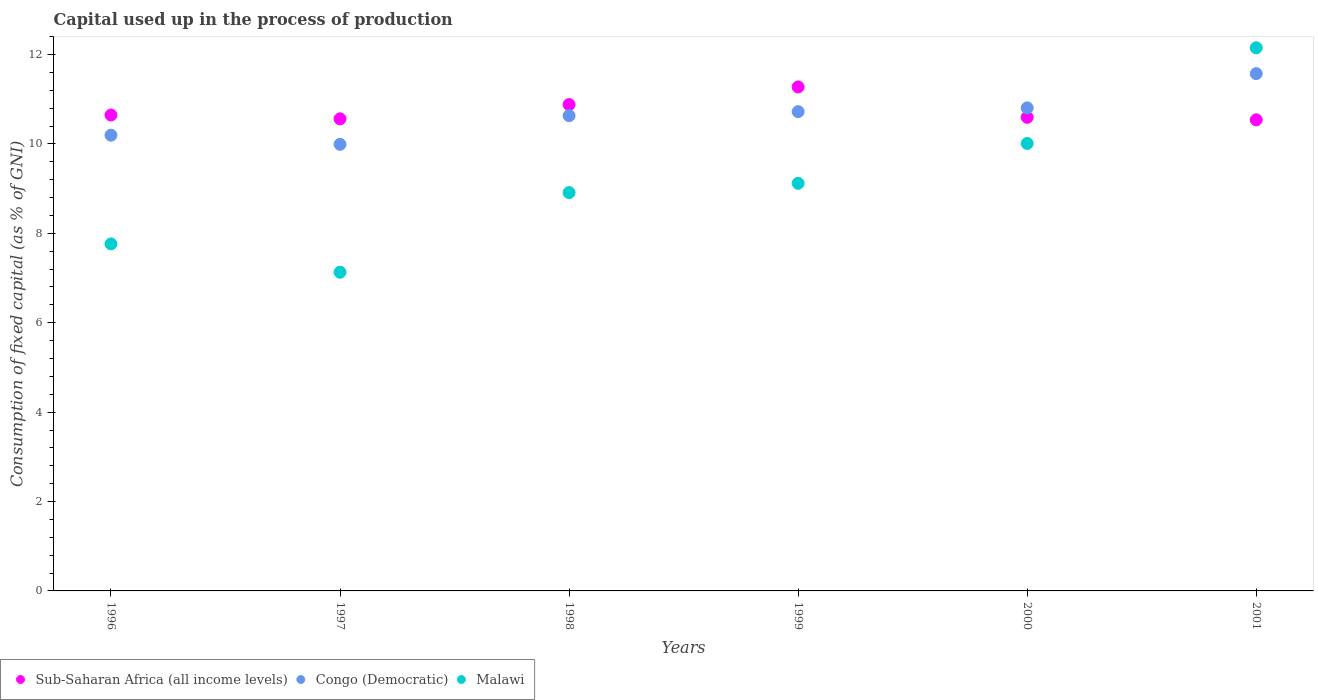What is the capital used up in the process of production in Congo (Democratic) in 2000?
Offer a terse response. 10.81. Across all years, what is the maximum capital used up in the process of production in Sub-Saharan Africa (all income levels)?
Offer a terse response. 11.27. Across all years, what is the minimum capital used up in the process of production in Malawi?
Ensure brevity in your answer.  7.13. In which year was the capital used up in the process of production in Sub-Saharan Africa (all income levels) maximum?
Make the answer very short. 1999. In which year was the capital used up in the process of production in Sub-Saharan Africa (all income levels) minimum?
Offer a terse response. 2001. What is the total capital used up in the process of production in Malawi in the graph?
Your response must be concise. 55.08. What is the difference between the capital used up in the process of production in Malawi in 1996 and that in 1999?
Your answer should be very brief. -1.36. What is the difference between the capital used up in the process of production in Malawi in 1997 and the capital used up in the process of production in Congo (Democratic) in 2001?
Offer a terse response. -4.44. What is the average capital used up in the process of production in Congo (Democratic) per year?
Keep it short and to the point. 10.65. In the year 1999, what is the difference between the capital used up in the process of production in Malawi and capital used up in the process of production in Congo (Democratic)?
Give a very brief answer. -1.6. In how many years, is the capital used up in the process of production in Congo (Democratic) greater than 1.6 %?
Offer a terse response. 6. What is the ratio of the capital used up in the process of production in Sub-Saharan Africa (all income levels) in 2000 to that in 2001?
Your answer should be compact. 1.01. Is the capital used up in the process of production in Sub-Saharan Africa (all income levels) in 1997 less than that in 2000?
Make the answer very short. Yes. Is the difference between the capital used up in the process of production in Malawi in 1998 and 1999 greater than the difference between the capital used up in the process of production in Congo (Democratic) in 1998 and 1999?
Your answer should be very brief. No. What is the difference between the highest and the second highest capital used up in the process of production in Sub-Saharan Africa (all income levels)?
Provide a succinct answer. 0.39. What is the difference between the highest and the lowest capital used up in the process of production in Sub-Saharan Africa (all income levels)?
Offer a very short reply. 0.74. In how many years, is the capital used up in the process of production in Sub-Saharan Africa (all income levels) greater than the average capital used up in the process of production in Sub-Saharan Africa (all income levels) taken over all years?
Provide a short and direct response. 2. Is the sum of the capital used up in the process of production in Congo (Democratic) in 1996 and 1997 greater than the maximum capital used up in the process of production in Sub-Saharan Africa (all income levels) across all years?
Your answer should be compact. Yes. How many dotlines are there?
Your response must be concise. 3. How many years are there in the graph?
Make the answer very short. 6. Are the values on the major ticks of Y-axis written in scientific E-notation?
Offer a very short reply. No. Does the graph contain grids?
Provide a succinct answer. No. How many legend labels are there?
Offer a very short reply. 3. What is the title of the graph?
Ensure brevity in your answer.  Capital used up in the process of production. What is the label or title of the Y-axis?
Your answer should be very brief. Consumption of fixed capital (as % of GNI). What is the Consumption of fixed capital (as % of GNI) in Sub-Saharan Africa (all income levels) in 1996?
Ensure brevity in your answer.  10.65. What is the Consumption of fixed capital (as % of GNI) in Congo (Democratic) in 1996?
Your answer should be compact. 10.2. What is the Consumption of fixed capital (as % of GNI) in Malawi in 1996?
Provide a short and direct response. 7.76. What is the Consumption of fixed capital (as % of GNI) of Sub-Saharan Africa (all income levels) in 1997?
Offer a terse response. 10.56. What is the Consumption of fixed capital (as % of GNI) of Congo (Democratic) in 1997?
Offer a terse response. 9.99. What is the Consumption of fixed capital (as % of GNI) in Malawi in 1997?
Make the answer very short. 7.13. What is the Consumption of fixed capital (as % of GNI) in Sub-Saharan Africa (all income levels) in 1998?
Your answer should be very brief. 10.88. What is the Consumption of fixed capital (as % of GNI) in Congo (Democratic) in 1998?
Your answer should be very brief. 10.63. What is the Consumption of fixed capital (as % of GNI) in Malawi in 1998?
Your answer should be compact. 8.91. What is the Consumption of fixed capital (as % of GNI) of Sub-Saharan Africa (all income levels) in 1999?
Offer a terse response. 11.27. What is the Consumption of fixed capital (as % of GNI) in Congo (Democratic) in 1999?
Keep it short and to the point. 10.72. What is the Consumption of fixed capital (as % of GNI) of Malawi in 1999?
Keep it short and to the point. 9.12. What is the Consumption of fixed capital (as % of GNI) of Sub-Saharan Africa (all income levels) in 2000?
Your answer should be very brief. 10.6. What is the Consumption of fixed capital (as % of GNI) in Congo (Democratic) in 2000?
Your answer should be compact. 10.81. What is the Consumption of fixed capital (as % of GNI) in Malawi in 2000?
Your response must be concise. 10.01. What is the Consumption of fixed capital (as % of GNI) of Sub-Saharan Africa (all income levels) in 2001?
Your answer should be very brief. 10.54. What is the Consumption of fixed capital (as % of GNI) of Congo (Democratic) in 2001?
Provide a short and direct response. 11.57. What is the Consumption of fixed capital (as % of GNI) of Malawi in 2001?
Your response must be concise. 12.15. Across all years, what is the maximum Consumption of fixed capital (as % of GNI) of Sub-Saharan Africa (all income levels)?
Make the answer very short. 11.27. Across all years, what is the maximum Consumption of fixed capital (as % of GNI) in Congo (Democratic)?
Provide a short and direct response. 11.57. Across all years, what is the maximum Consumption of fixed capital (as % of GNI) in Malawi?
Your answer should be very brief. 12.15. Across all years, what is the minimum Consumption of fixed capital (as % of GNI) in Sub-Saharan Africa (all income levels)?
Keep it short and to the point. 10.54. Across all years, what is the minimum Consumption of fixed capital (as % of GNI) in Congo (Democratic)?
Offer a very short reply. 9.99. Across all years, what is the minimum Consumption of fixed capital (as % of GNI) of Malawi?
Provide a succinct answer. 7.13. What is the total Consumption of fixed capital (as % of GNI) of Sub-Saharan Africa (all income levels) in the graph?
Keep it short and to the point. 64.5. What is the total Consumption of fixed capital (as % of GNI) in Congo (Democratic) in the graph?
Your response must be concise. 63.92. What is the total Consumption of fixed capital (as % of GNI) of Malawi in the graph?
Your answer should be compact. 55.08. What is the difference between the Consumption of fixed capital (as % of GNI) of Sub-Saharan Africa (all income levels) in 1996 and that in 1997?
Your response must be concise. 0.09. What is the difference between the Consumption of fixed capital (as % of GNI) in Congo (Democratic) in 1996 and that in 1997?
Ensure brevity in your answer.  0.2. What is the difference between the Consumption of fixed capital (as % of GNI) in Malawi in 1996 and that in 1997?
Offer a terse response. 0.63. What is the difference between the Consumption of fixed capital (as % of GNI) in Sub-Saharan Africa (all income levels) in 1996 and that in 1998?
Your answer should be very brief. -0.23. What is the difference between the Consumption of fixed capital (as % of GNI) in Congo (Democratic) in 1996 and that in 1998?
Offer a terse response. -0.44. What is the difference between the Consumption of fixed capital (as % of GNI) of Malawi in 1996 and that in 1998?
Offer a terse response. -1.15. What is the difference between the Consumption of fixed capital (as % of GNI) of Sub-Saharan Africa (all income levels) in 1996 and that in 1999?
Keep it short and to the point. -0.63. What is the difference between the Consumption of fixed capital (as % of GNI) of Congo (Democratic) in 1996 and that in 1999?
Your answer should be very brief. -0.53. What is the difference between the Consumption of fixed capital (as % of GNI) in Malawi in 1996 and that in 1999?
Provide a short and direct response. -1.36. What is the difference between the Consumption of fixed capital (as % of GNI) of Sub-Saharan Africa (all income levels) in 1996 and that in 2000?
Your answer should be compact. 0.05. What is the difference between the Consumption of fixed capital (as % of GNI) of Congo (Democratic) in 1996 and that in 2000?
Ensure brevity in your answer.  -0.61. What is the difference between the Consumption of fixed capital (as % of GNI) of Malawi in 1996 and that in 2000?
Provide a succinct answer. -2.25. What is the difference between the Consumption of fixed capital (as % of GNI) of Sub-Saharan Africa (all income levels) in 1996 and that in 2001?
Keep it short and to the point. 0.11. What is the difference between the Consumption of fixed capital (as % of GNI) in Congo (Democratic) in 1996 and that in 2001?
Your answer should be very brief. -1.38. What is the difference between the Consumption of fixed capital (as % of GNI) of Malawi in 1996 and that in 2001?
Provide a short and direct response. -4.39. What is the difference between the Consumption of fixed capital (as % of GNI) of Sub-Saharan Africa (all income levels) in 1997 and that in 1998?
Ensure brevity in your answer.  -0.32. What is the difference between the Consumption of fixed capital (as % of GNI) in Congo (Democratic) in 1997 and that in 1998?
Offer a very short reply. -0.64. What is the difference between the Consumption of fixed capital (as % of GNI) of Malawi in 1997 and that in 1998?
Make the answer very short. -1.78. What is the difference between the Consumption of fixed capital (as % of GNI) in Sub-Saharan Africa (all income levels) in 1997 and that in 1999?
Your answer should be compact. -0.71. What is the difference between the Consumption of fixed capital (as % of GNI) in Congo (Democratic) in 1997 and that in 1999?
Give a very brief answer. -0.73. What is the difference between the Consumption of fixed capital (as % of GNI) in Malawi in 1997 and that in 1999?
Your response must be concise. -1.99. What is the difference between the Consumption of fixed capital (as % of GNI) in Sub-Saharan Africa (all income levels) in 1997 and that in 2000?
Provide a short and direct response. -0.03. What is the difference between the Consumption of fixed capital (as % of GNI) of Congo (Democratic) in 1997 and that in 2000?
Give a very brief answer. -0.82. What is the difference between the Consumption of fixed capital (as % of GNI) in Malawi in 1997 and that in 2000?
Offer a very short reply. -2.88. What is the difference between the Consumption of fixed capital (as % of GNI) in Sub-Saharan Africa (all income levels) in 1997 and that in 2001?
Give a very brief answer. 0.02. What is the difference between the Consumption of fixed capital (as % of GNI) in Congo (Democratic) in 1997 and that in 2001?
Your answer should be compact. -1.58. What is the difference between the Consumption of fixed capital (as % of GNI) in Malawi in 1997 and that in 2001?
Your answer should be very brief. -5.02. What is the difference between the Consumption of fixed capital (as % of GNI) of Sub-Saharan Africa (all income levels) in 1998 and that in 1999?
Your answer should be very brief. -0.39. What is the difference between the Consumption of fixed capital (as % of GNI) of Congo (Democratic) in 1998 and that in 1999?
Offer a very short reply. -0.09. What is the difference between the Consumption of fixed capital (as % of GNI) of Malawi in 1998 and that in 1999?
Keep it short and to the point. -0.21. What is the difference between the Consumption of fixed capital (as % of GNI) in Sub-Saharan Africa (all income levels) in 1998 and that in 2000?
Ensure brevity in your answer.  0.28. What is the difference between the Consumption of fixed capital (as % of GNI) of Congo (Democratic) in 1998 and that in 2000?
Your response must be concise. -0.18. What is the difference between the Consumption of fixed capital (as % of GNI) in Malawi in 1998 and that in 2000?
Provide a short and direct response. -1.1. What is the difference between the Consumption of fixed capital (as % of GNI) of Sub-Saharan Africa (all income levels) in 1998 and that in 2001?
Your response must be concise. 0.34. What is the difference between the Consumption of fixed capital (as % of GNI) in Congo (Democratic) in 1998 and that in 2001?
Your response must be concise. -0.94. What is the difference between the Consumption of fixed capital (as % of GNI) in Malawi in 1998 and that in 2001?
Offer a very short reply. -3.24. What is the difference between the Consumption of fixed capital (as % of GNI) of Sub-Saharan Africa (all income levels) in 1999 and that in 2000?
Provide a succinct answer. 0.68. What is the difference between the Consumption of fixed capital (as % of GNI) of Congo (Democratic) in 1999 and that in 2000?
Make the answer very short. -0.08. What is the difference between the Consumption of fixed capital (as % of GNI) of Malawi in 1999 and that in 2000?
Provide a short and direct response. -0.89. What is the difference between the Consumption of fixed capital (as % of GNI) of Sub-Saharan Africa (all income levels) in 1999 and that in 2001?
Offer a terse response. 0.74. What is the difference between the Consumption of fixed capital (as % of GNI) in Congo (Democratic) in 1999 and that in 2001?
Your response must be concise. -0.85. What is the difference between the Consumption of fixed capital (as % of GNI) of Malawi in 1999 and that in 2001?
Your response must be concise. -3.03. What is the difference between the Consumption of fixed capital (as % of GNI) of Sub-Saharan Africa (all income levels) in 2000 and that in 2001?
Give a very brief answer. 0.06. What is the difference between the Consumption of fixed capital (as % of GNI) in Congo (Democratic) in 2000 and that in 2001?
Offer a very short reply. -0.77. What is the difference between the Consumption of fixed capital (as % of GNI) of Malawi in 2000 and that in 2001?
Your answer should be very brief. -2.14. What is the difference between the Consumption of fixed capital (as % of GNI) of Sub-Saharan Africa (all income levels) in 1996 and the Consumption of fixed capital (as % of GNI) of Congo (Democratic) in 1997?
Give a very brief answer. 0.66. What is the difference between the Consumption of fixed capital (as % of GNI) of Sub-Saharan Africa (all income levels) in 1996 and the Consumption of fixed capital (as % of GNI) of Malawi in 1997?
Provide a short and direct response. 3.52. What is the difference between the Consumption of fixed capital (as % of GNI) of Congo (Democratic) in 1996 and the Consumption of fixed capital (as % of GNI) of Malawi in 1997?
Your answer should be compact. 3.07. What is the difference between the Consumption of fixed capital (as % of GNI) in Sub-Saharan Africa (all income levels) in 1996 and the Consumption of fixed capital (as % of GNI) in Congo (Democratic) in 1998?
Provide a succinct answer. 0.02. What is the difference between the Consumption of fixed capital (as % of GNI) in Sub-Saharan Africa (all income levels) in 1996 and the Consumption of fixed capital (as % of GNI) in Malawi in 1998?
Your answer should be very brief. 1.74. What is the difference between the Consumption of fixed capital (as % of GNI) of Congo (Democratic) in 1996 and the Consumption of fixed capital (as % of GNI) of Malawi in 1998?
Keep it short and to the point. 1.28. What is the difference between the Consumption of fixed capital (as % of GNI) in Sub-Saharan Africa (all income levels) in 1996 and the Consumption of fixed capital (as % of GNI) in Congo (Democratic) in 1999?
Provide a short and direct response. -0.08. What is the difference between the Consumption of fixed capital (as % of GNI) of Sub-Saharan Africa (all income levels) in 1996 and the Consumption of fixed capital (as % of GNI) of Malawi in 1999?
Give a very brief answer. 1.53. What is the difference between the Consumption of fixed capital (as % of GNI) of Congo (Democratic) in 1996 and the Consumption of fixed capital (as % of GNI) of Malawi in 1999?
Your response must be concise. 1.08. What is the difference between the Consumption of fixed capital (as % of GNI) in Sub-Saharan Africa (all income levels) in 1996 and the Consumption of fixed capital (as % of GNI) in Congo (Democratic) in 2000?
Make the answer very short. -0.16. What is the difference between the Consumption of fixed capital (as % of GNI) in Sub-Saharan Africa (all income levels) in 1996 and the Consumption of fixed capital (as % of GNI) in Malawi in 2000?
Your response must be concise. 0.64. What is the difference between the Consumption of fixed capital (as % of GNI) of Congo (Democratic) in 1996 and the Consumption of fixed capital (as % of GNI) of Malawi in 2000?
Your answer should be compact. 0.19. What is the difference between the Consumption of fixed capital (as % of GNI) in Sub-Saharan Africa (all income levels) in 1996 and the Consumption of fixed capital (as % of GNI) in Congo (Democratic) in 2001?
Your answer should be very brief. -0.93. What is the difference between the Consumption of fixed capital (as % of GNI) of Sub-Saharan Africa (all income levels) in 1996 and the Consumption of fixed capital (as % of GNI) of Malawi in 2001?
Make the answer very short. -1.5. What is the difference between the Consumption of fixed capital (as % of GNI) in Congo (Democratic) in 1996 and the Consumption of fixed capital (as % of GNI) in Malawi in 2001?
Your answer should be very brief. -1.96. What is the difference between the Consumption of fixed capital (as % of GNI) of Sub-Saharan Africa (all income levels) in 1997 and the Consumption of fixed capital (as % of GNI) of Congo (Democratic) in 1998?
Offer a terse response. -0.07. What is the difference between the Consumption of fixed capital (as % of GNI) in Sub-Saharan Africa (all income levels) in 1997 and the Consumption of fixed capital (as % of GNI) in Malawi in 1998?
Your answer should be very brief. 1.65. What is the difference between the Consumption of fixed capital (as % of GNI) of Congo (Democratic) in 1997 and the Consumption of fixed capital (as % of GNI) of Malawi in 1998?
Make the answer very short. 1.08. What is the difference between the Consumption of fixed capital (as % of GNI) of Sub-Saharan Africa (all income levels) in 1997 and the Consumption of fixed capital (as % of GNI) of Congo (Democratic) in 1999?
Give a very brief answer. -0.16. What is the difference between the Consumption of fixed capital (as % of GNI) of Sub-Saharan Africa (all income levels) in 1997 and the Consumption of fixed capital (as % of GNI) of Malawi in 1999?
Provide a succinct answer. 1.44. What is the difference between the Consumption of fixed capital (as % of GNI) of Congo (Democratic) in 1997 and the Consumption of fixed capital (as % of GNI) of Malawi in 1999?
Your response must be concise. 0.87. What is the difference between the Consumption of fixed capital (as % of GNI) in Sub-Saharan Africa (all income levels) in 1997 and the Consumption of fixed capital (as % of GNI) in Congo (Democratic) in 2000?
Provide a short and direct response. -0.25. What is the difference between the Consumption of fixed capital (as % of GNI) of Sub-Saharan Africa (all income levels) in 1997 and the Consumption of fixed capital (as % of GNI) of Malawi in 2000?
Provide a succinct answer. 0.55. What is the difference between the Consumption of fixed capital (as % of GNI) of Congo (Democratic) in 1997 and the Consumption of fixed capital (as % of GNI) of Malawi in 2000?
Give a very brief answer. -0.02. What is the difference between the Consumption of fixed capital (as % of GNI) of Sub-Saharan Africa (all income levels) in 1997 and the Consumption of fixed capital (as % of GNI) of Congo (Democratic) in 2001?
Provide a short and direct response. -1.01. What is the difference between the Consumption of fixed capital (as % of GNI) of Sub-Saharan Africa (all income levels) in 1997 and the Consumption of fixed capital (as % of GNI) of Malawi in 2001?
Your response must be concise. -1.59. What is the difference between the Consumption of fixed capital (as % of GNI) of Congo (Democratic) in 1997 and the Consumption of fixed capital (as % of GNI) of Malawi in 2001?
Ensure brevity in your answer.  -2.16. What is the difference between the Consumption of fixed capital (as % of GNI) of Sub-Saharan Africa (all income levels) in 1998 and the Consumption of fixed capital (as % of GNI) of Congo (Democratic) in 1999?
Ensure brevity in your answer.  0.16. What is the difference between the Consumption of fixed capital (as % of GNI) in Sub-Saharan Africa (all income levels) in 1998 and the Consumption of fixed capital (as % of GNI) in Malawi in 1999?
Provide a succinct answer. 1.76. What is the difference between the Consumption of fixed capital (as % of GNI) in Congo (Democratic) in 1998 and the Consumption of fixed capital (as % of GNI) in Malawi in 1999?
Make the answer very short. 1.51. What is the difference between the Consumption of fixed capital (as % of GNI) of Sub-Saharan Africa (all income levels) in 1998 and the Consumption of fixed capital (as % of GNI) of Congo (Democratic) in 2000?
Provide a succinct answer. 0.07. What is the difference between the Consumption of fixed capital (as % of GNI) of Sub-Saharan Africa (all income levels) in 1998 and the Consumption of fixed capital (as % of GNI) of Malawi in 2000?
Your response must be concise. 0.87. What is the difference between the Consumption of fixed capital (as % of GNI) in Congo (Democratic) in 1998 and the Consumption of fixed capital (as % of GNI) in Malawi in 2000?
Your answer should be very brief. 0.62. What is the difference between the Consumption of fixed capital (as % of GNI) in Sub-Saharan Africa (all income levels) in 1998 and the Consumption of fixed capital (as % of GNI) in Congo (Democratic) in 2001?
Offer a very short reply. -0.69. What is the difference between the Consumption of fixed capital (as % of GNI) of Sub-Saharan Africa (all income levels) in 1998 and the Consumption of fixed capital (as % of GNI) of Malawi in 2001?
Ensure brevity in your answer.  -1.27. What is the difference between the Consumption of fixed capital (as % of GNI) in Congo (Democratic) in 1998 and the Consumption of fixed capital (as % of GNI) in Malawi in 2001?
Your answer should be very brief. -1.52. What is the difference between the Consumption of fixed capital (as % of GNI) of Sub-Saharan Africa (all income levels) in 1999 and the Consumption of fixed capital (as % of GNI) of Congo (Democratic) in 2000?
Your answer should be very brief. 0.47. What is the difference between the Consumption of fixed capital (as % of GNI) of Sub-Saharan Africa (all income levels) in 1999 and the Consumption of fixed capital (as % of GNI) of Malawi in 2000?
Offer a very short reply. 1.26. What is the difference between the Consumption of fixed capital (as % of GNI) of Congo (Democratic) in 1999 and the Consumption of fixed capital (as % of GNI) of Malawi in 2000?
Ensure brevity in your answer.  0.71. What is the difference between the Consumption of fixed capital (as % of GNI) of Sub-Saharan Africa (all income levels) in 1999 and the Consumption of fixed capital (as % of GNI) of Congo (Democratic) in 2001?
Your answer should be very brief. -0.3. What is the difference between the Consumption of fixed capital (as % of GNI) of Sub-Saharan Africa (all income levels) in 1999 and the Consumption of fixed capital (as % of GNI) of Malawi in 2001?
Offer a terse response. -0.88. What is the difference between the Consumption of fixed capital (as % of GNI) of Congo (Democratic) in 1999 and the Consumption of fixed capital (as % of GNI) of Malawi in 2001?
Provide a succinct answer. -1.43. What is the difference between the Consumption of fixed capital (as % of GNI) in Sub-Saharan Africa (all income levels) in 2000 and the Consumption of fixed capital (as % of GNI) in Congo (Democratic) in 2001?
Offer a terse response. -0.98. What is the difference between the Consumption of fixed capital (as % of GNI) of Sub-Saharan Africa (all income levels) in 2000 and the Consumption of fixed capital (as % of GNI) of Malawi in 2001?
Keep it short and to the point. -1.55. What is the difference between the Consumption of fixed capital (as % of GNI) of Congo (Democratic) in 2000 and the Consumption of fixed capital (as % of GNI) of Malawi in 2001?
Provide a short and direct response. -1.34. What is the average Consumption of fixed capital (as % of GNI) in Sub-Saharan Africa (all income levels) per year?
Your answer should be compact. 10.75. What is the average Consumption of fixed capital (as % of GNI) in Congo (Democratic) per year?
Make the answer very short. 10.65. What is the average Consumption of fixed capital (as % of GNI) of Malawi per year?
Provide a succinct answer. 9.18. In the year 1996, what is the difference between the Consumption of fixed capital (as % of GNI) in Sub-Saharan Africa (all income levels) and Consumption of fixed capital (as % of GNI) in Congo (Democratic)?
Provide a short and direct response. 0.45. In the year 1996, what is the difference between the Consumption of fixed capital (as % of GNI) of Sub-Saharan Africa (all income levels) and Consumption of fixed capital (as % of GNI) of Malawi?
Provide a short and direct response. 2.88. In the year 1996, what is the difference between the Consumption of fixed capital (as % of GNI) of Congo (Democratic) and Consumption of fixed capital (as % of GNI) of Malawi?
Ensure brevity in your answer.  2.43. In the year 1997, what is the difference between the Consumption of fixed capital (as % of GNI) in Sub-Saharan Africa (all income levels) and Consumption of fixed capital (as % of GNI) in Congo (Democratic)?
Provide a succinct answer. 0.57. In the year 1997, what is the difference between the Consumption of fixed capital (as % of GNI) in Sub-Saharan Africa (all income levels) and Consumption of fixed capital (as % of GNI) in Malawi?
Give a very brief answer. 3.43. In the year 1997, what is the difference between the Consumption of fixed capital (as % of GNI) in Congo (Democratic) and Consumption of fixed capital (as % of GNI) in Malawi?
Provide a succinct answer. 2.86. In the year 1998, what is the difference between the Consumption of fixed capital (as % of GNI) of Sub-Saharan Africa (all income levels) and Consumption of fixed capital (as % of GNI) of Congo (Democratic)?
Give a very brief answer. 0.25. In the year 1998, what is the difference between the Consumption of fixed capital (as % of GNI) of Sub-Saharan Africa (all income levels) and Consumption of fixed capital (as % of GNI) of Malawi?
Offer a terse response. 1.97. In the year 1998, what is the difference between the Consumption of fixed capital (as % of GNI) in Congo (Democratic) and Consumption of fixed capital (as % of GNI) in Malawi?
Give a very brief answer. 1.72. In the year 1999, what is the difference between the Consumption of fixed capital (as % of GNI) in Sub-Saharan Africa (all income levels) and Consumption of fixed capital (as % of GNI) in Congo (Democratic)?
Ensure brevity in your answer.  0.55. In the year 1999, what is the difference between the Consumption of fixed capital (as % of GNI) in Sub-Saharan Africa (all income levels) and Consumption of fixed capital (as % of GNI) in Malawi?
Your response must be concise. 2.16. In the year 1999, what is the difference between the Consumption of fixed capital (as % of GNI) in Congo (Democratic) and Consumption of fixed capital (as % of GNI) in Malawi?
Offer a terse response. 1.6. In the year 2000, what is the difference between the Consumption of fixed capital (as % of GNI) in Sub-Saharan Africa (all income levels) and Consumption of fixed capital (as % of GNI) in Congo (Democratic)?
Ensure brevity in your answer.  -0.21. In the year 2000, what is the difference between the Consumption of fixed capital (as % of GNI) of Sub-Saharan Africa (all income levels) and Consumption of fixed capital (as % of GNI) of Malawi?
Provide a succinct answer. 0.59. In the year 2000, what is the difference between the Consumption of fixed capital (as % of GNI) in Congo (Democratic) and Consumption of fixed capital (as % of GNI) in Malawi?
Make the answer very short. 0.8. In the year 2001, what is the difference between the Consumption of fixed capital (as % of GNI) in Sub-Saharan Africa (all income levels) and Consumption of fixed capital (as % of GNI) in Congo (Democratic)?
Your answer should be compact. -1.03. In the year 2001, what is the difference between the Consumption of fixed capital (as % of GNI) of Sub-Saharan Africa (all income levels) and Consumption of fixed capital (as % of GNI) of Malawi?
Your answer should be compact. -1.61. In the year 2001, what is the difference between the Consumption of fixed capital (as % of GNI) in Congo (Democratic) and Consumption of fixed capital (as % of GNI) in Malawi?
Your response must be concise. -0.58. What is the ratio of the Consumption of fixed capital (as % of GNI) of Congo (Democratic) in 1996 to that in 1997?
Keep it short and to the point. 1.02. What is the ratio of the Consumption of fixed capital (as % of GNI) of Malawi in 1996 to that in 1997?
Ensure brevity in your answer.  1.09. What is the ratio of the Consumption of fixed capital (as % of GNI) in Sub-Saharan Africa (all income levels) in 1996 to that in 1998?
Your answer should be compact. 0.98. What is the ratio of the Consumption of fixed capital (as % of GNI) of Malawi in 1996 to that in 1998?
Ensure brevity in your answer.  0.87. What is the ratio of the Consumption of fixed capital (as % of GNI) in Sub-Saharan Africa (all income levels) in 1996 to that in 1999?
Provide a succinct answer. 0.94. What is the ratio of the Consumption of fixed capital (as % of GNI) in Congo (Democratic) in 1996 to that in 1999?
Your response must be concise. 0.95. What is the ratio of the Consumption of fixed capital (as % of GNI) of Malawi in 1996 to that in 1999?
Offer a terse response. 0.85. What is the ratio of the Consumption of fixed capital (as % of GNI) in Sub-Saharan Africa (all income levels) in 1996 to that in 2000?
Your response must be concise. 1. What is the ratio of the Consumption of fixed capital (as % of GNI) of Congo (Democratic) in 1996 to that in 2000?
Provide a succinct answer. 0.94. What is the ratio of the Consumption of fixed capital (as % of GNI) in Malawi in 1996 to that in 2000?
Give a very brief answer. 0.78. What is the ratio of the Consumption of fixed capital (as % of GNI) in Sub-Saharan Africa (all income levels) in 1996 to that in 2001?
Make the answer very short. 1.01. What is the ratio of the Consumption of fixed capital (as % of GNI) of Congo (Democratic) in 1996 to that in 2001?
Keep it short and to the point. 0.88. What is the ratio of the Consumption of fixed capital (as % of GNI) in Malawi in 1996 to that in 2001?
Your answer should be compact. 0.64. What is the ratio of the Consumption of fixed capital (as % of GNI) in Sub-Saharan Africa (all income levels) in 1997 to that in 1998?
Your answer should be compact. 0.97. What is the ratio of the Consumption of fixed capital (as % of GNI) of Congo (Democratic) in 1997 to that in 1998?
Your response must be concise. 0.94. What is the ratio of the Consumption of fixed capital (as % of GNI) of Sub-Saharan Africa (all income levels) in 1997 to that in 1999?
Offer a terse response. 0.94. What is the ratio of the Consumption of fixed capital (as % of GNI) of Congo (Democratic) in 1997 to that in 1999?
Your response must be concise. 0.93. What is the ratio of the Consumption of fixed capital (as % of GNI) of Malawi in 1997 to that in 1999?
Keep it short and to the point. 0.78. What is the ratio of the Consumption of fixed capital (as % of GNI) in Sub-Saharan Africa (all income levels) in 1997 to that in 2000?
Your response must be concise. 1. What is the ratio of the Consumption of fixed capital (as % of GNI) in Congo (Democratic) in 1997 to that in 2000?
Provide a succinct answer. 0.92. What is the ratio of the Consumption of fixed capital (as % of GNI) in Malawi in 1997 to that in 2000?
Make the answer very short. 0.71. What is the ratio of the Consumption of fixed capital (as % of GNI) in Sub-Saharan Africa (all income levels) in 1997 to that in 2001?
Your response must be concise. 1. What is the ratio of the Consumption of fixed capital (as % of GNI) of Congo (Democratic) in 1997 to that in 2001?
Give a very brief answer. 0.86. What is the ratio of the Consumption of fixed capital (as % of GNI) in Malawi in 1997 to that in 2001?
Offer a terse response. 0.59. What is the ratio of the Consumption of fixed capital (as % of GNI) in Sub-Saharan Africa (all income levels) in 1998 to that in 1999?
Your answer should be very brief. 0.97. What is the ratio of the Consumption of fixed capital (as % of GNI) in Congo (Democratic) in 1998 to that in 1999?
Make the answer very short. 0.99. What is the ratio of the Consumption of fixed capital (as % of GNI) of Malawi in 1998 to that in 1999?
Offer a very short reply. 0.98. What is the ratio of the Consumption of fixed capital (as % of GNI) of Sub-Saharan Africa (all income levels) in 1998 to that in 2000?
Your answer should be compact. 1.03. What is the ratio of the Consumption of fixed capital (as % of GNI) of Congo (Democratic) in 1998 to that in 2000?
Ensure brevity in your answer.  0.98. What is the ratio of the Consumption of fixed capital (as % of GNI) in Malawi in 1998 to that in 2000?
Your answer should be very brief. 0.89. What is the ratio of the Consumption of fixed capital (as % of GNI) in Sub-Saharan Africa (all income levels) in 1998 to that in 2001?
Your response must be concise. 1.03. What is the ratio of the Consumption of fixed capital (as % of GNI) in Congo (Democratic) in 1998 to that in 2001?
Your answer should be very brief. 0.92. What is the ratio of the Consumption of fixed capital (as % of GNI) in Malawi in 1998 to that in 2001?
Offer a very short reply. 0.73. What is the ratio of the Consumption of fixed capital (as % of GNI) of Sub-Saharan Africa (all income levels) in 1999 to that in 2000?
Your response must be concise. 1.06. What is the ratio of the Consumption of fixed capital (as % of GNI) of Malawi in 1999 to that in 2000?
Provide a short and direct response. 0.91. What is the ratio of the Consumption of fixed capital (as % of GNI) of Sub-Saharan Africa (all income levels) in 1999 to that in 2001?
Make the answer very short. 1.07. What is the ratio of the Consumption of fixed capital (as % of GNI) of Congo (Democratic) in 1999 to that in 2001?
Ensure brevity in your answer.  0.93. What is the ratio of the Consumption of fixed capital (as % of GNI) of Malawi in 1999 to that in 2001?
Your answer should be very brief. 0.75. What is the ratio of the Consumption of fixed capital (as % of GNI) in Sub-Saharan Africa (all income levels) in 2000 to that in 2001?
Keep it short and to the point. 1.01. What is the ratio of the Consumption of fixed capital (as % of GNI) in Congo (Democratic) in 2000 to that in 2001?
Make the answer very short. 0.93. What is the ratio of the Consumption of fixed capital (as % of GNI) of Malawi in 2000 to that in 2001?
Provide a succinct answer. 0.82. What is the difference between the highest and the second highest Consumption of fixed capital (as % of GNI) in Sub-Saharan Africa (all income levels)?
Offer a very short reply. 0.39. What is the difference between the highest and the second highest Consumption of fixed capital (as % of GNI) of Congo (Democratic)?
Ensure brevity in your answer.  0.77. What is the difference between the highest and the second highest Consumption of fixed capital (as % of GNI) in Malawi?
Give a very brief answer. 2.14. What is the difference between the highest and the lowest Consumption of fixed capital (as % of GNI) of Sub-Saharan Africa (all income levels)?
Your answer should be very brief. 0.74. What is the difference between the highest and the lowest Consumption of fixed capital (as % of GNI) of Congo (Democratic)?
Ensure brevity in your answer.  1.58. What is the difference between the highest and the lowest Consumption of fixed capital (as % of GNI) of Malawi?
Make the answer very short. 5.02. 